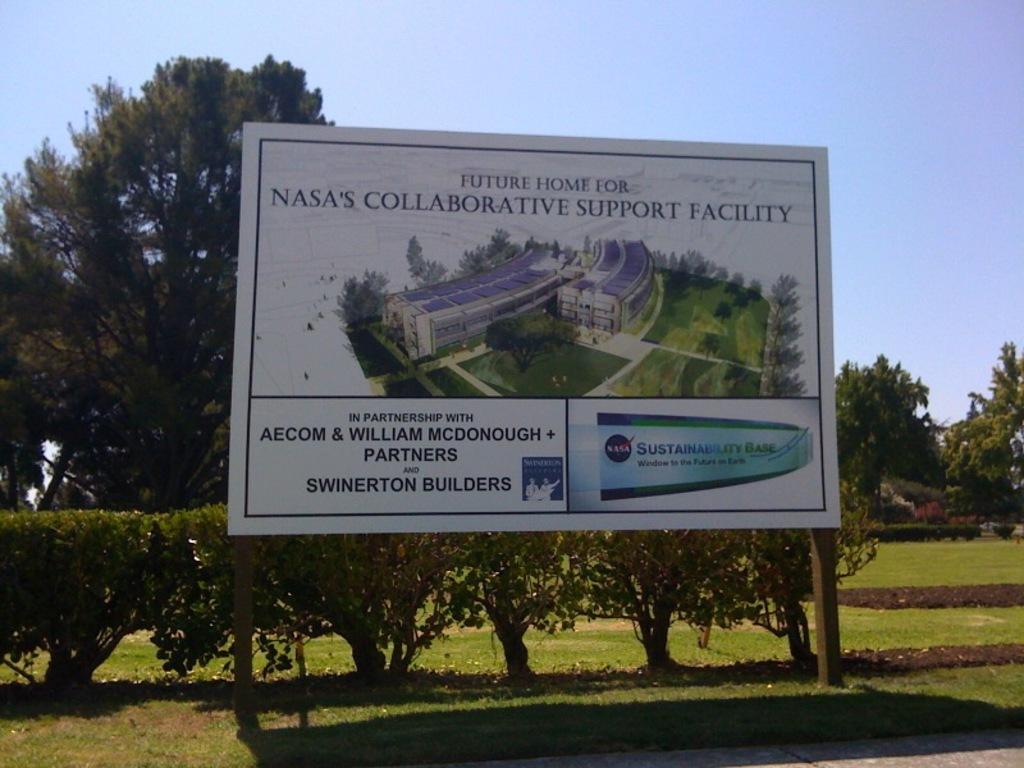Whose collaborative support facility will this be?
Keep it short and to the point. Nasa. Who are the partners involved?
Offer a very short reply. Aecom & william mcdonough. 